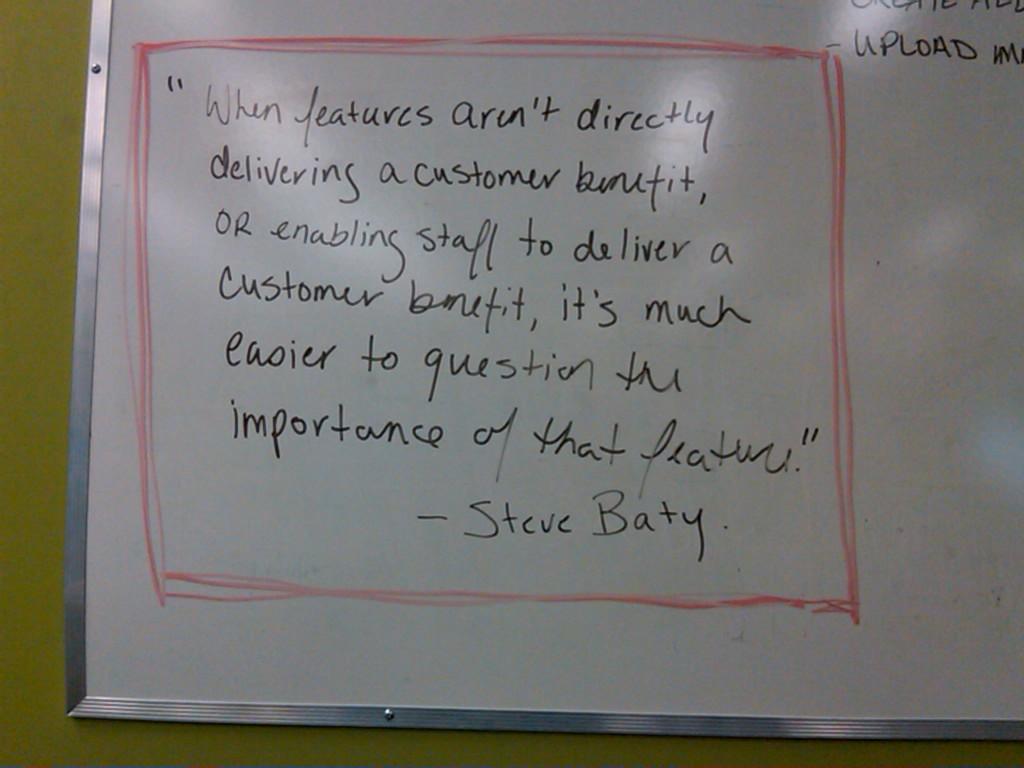Who said this quote?
Your answer should be compact. Steve baty. What is the first word in the quote?
Your response must be concise. When. 